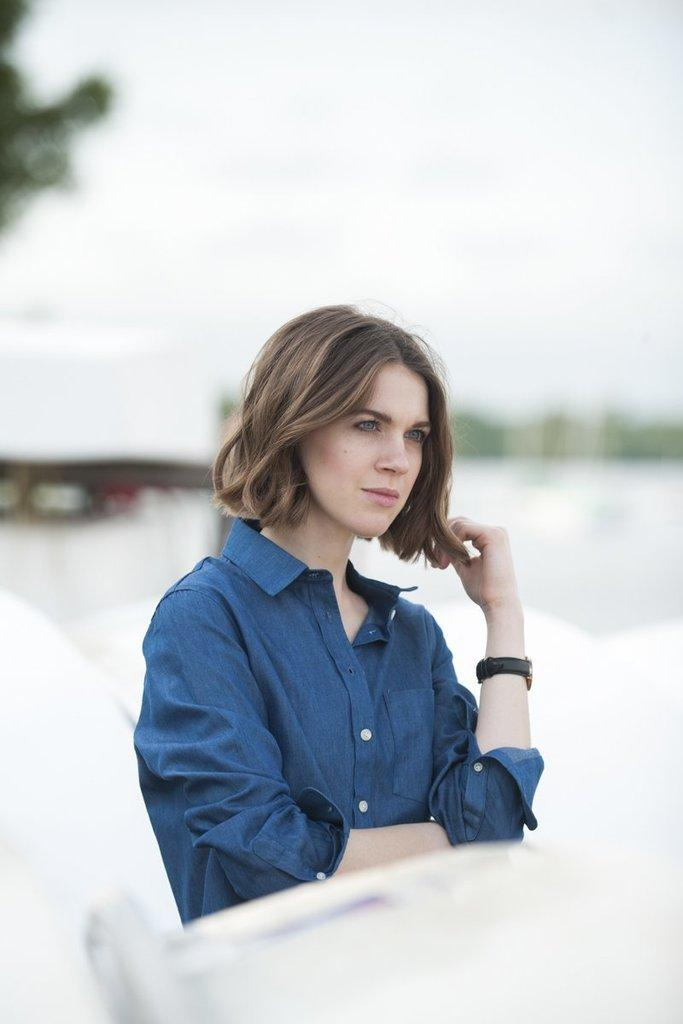Who is the main subject in the image? There is a woman in the image. Can you describe the background of the image? The background of the image is blurred. Where is the calendar located in the image? There is no calendar present in the image. What type of lock is visible on the woman's clothing? There is no lock visible on the woman's clothing in the image. 